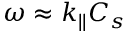Convert formula to latex. <formula><loc_0><loc_0><loc_500><loc_500>\omega \approx k _ { | | } C _ { s }</formula> 